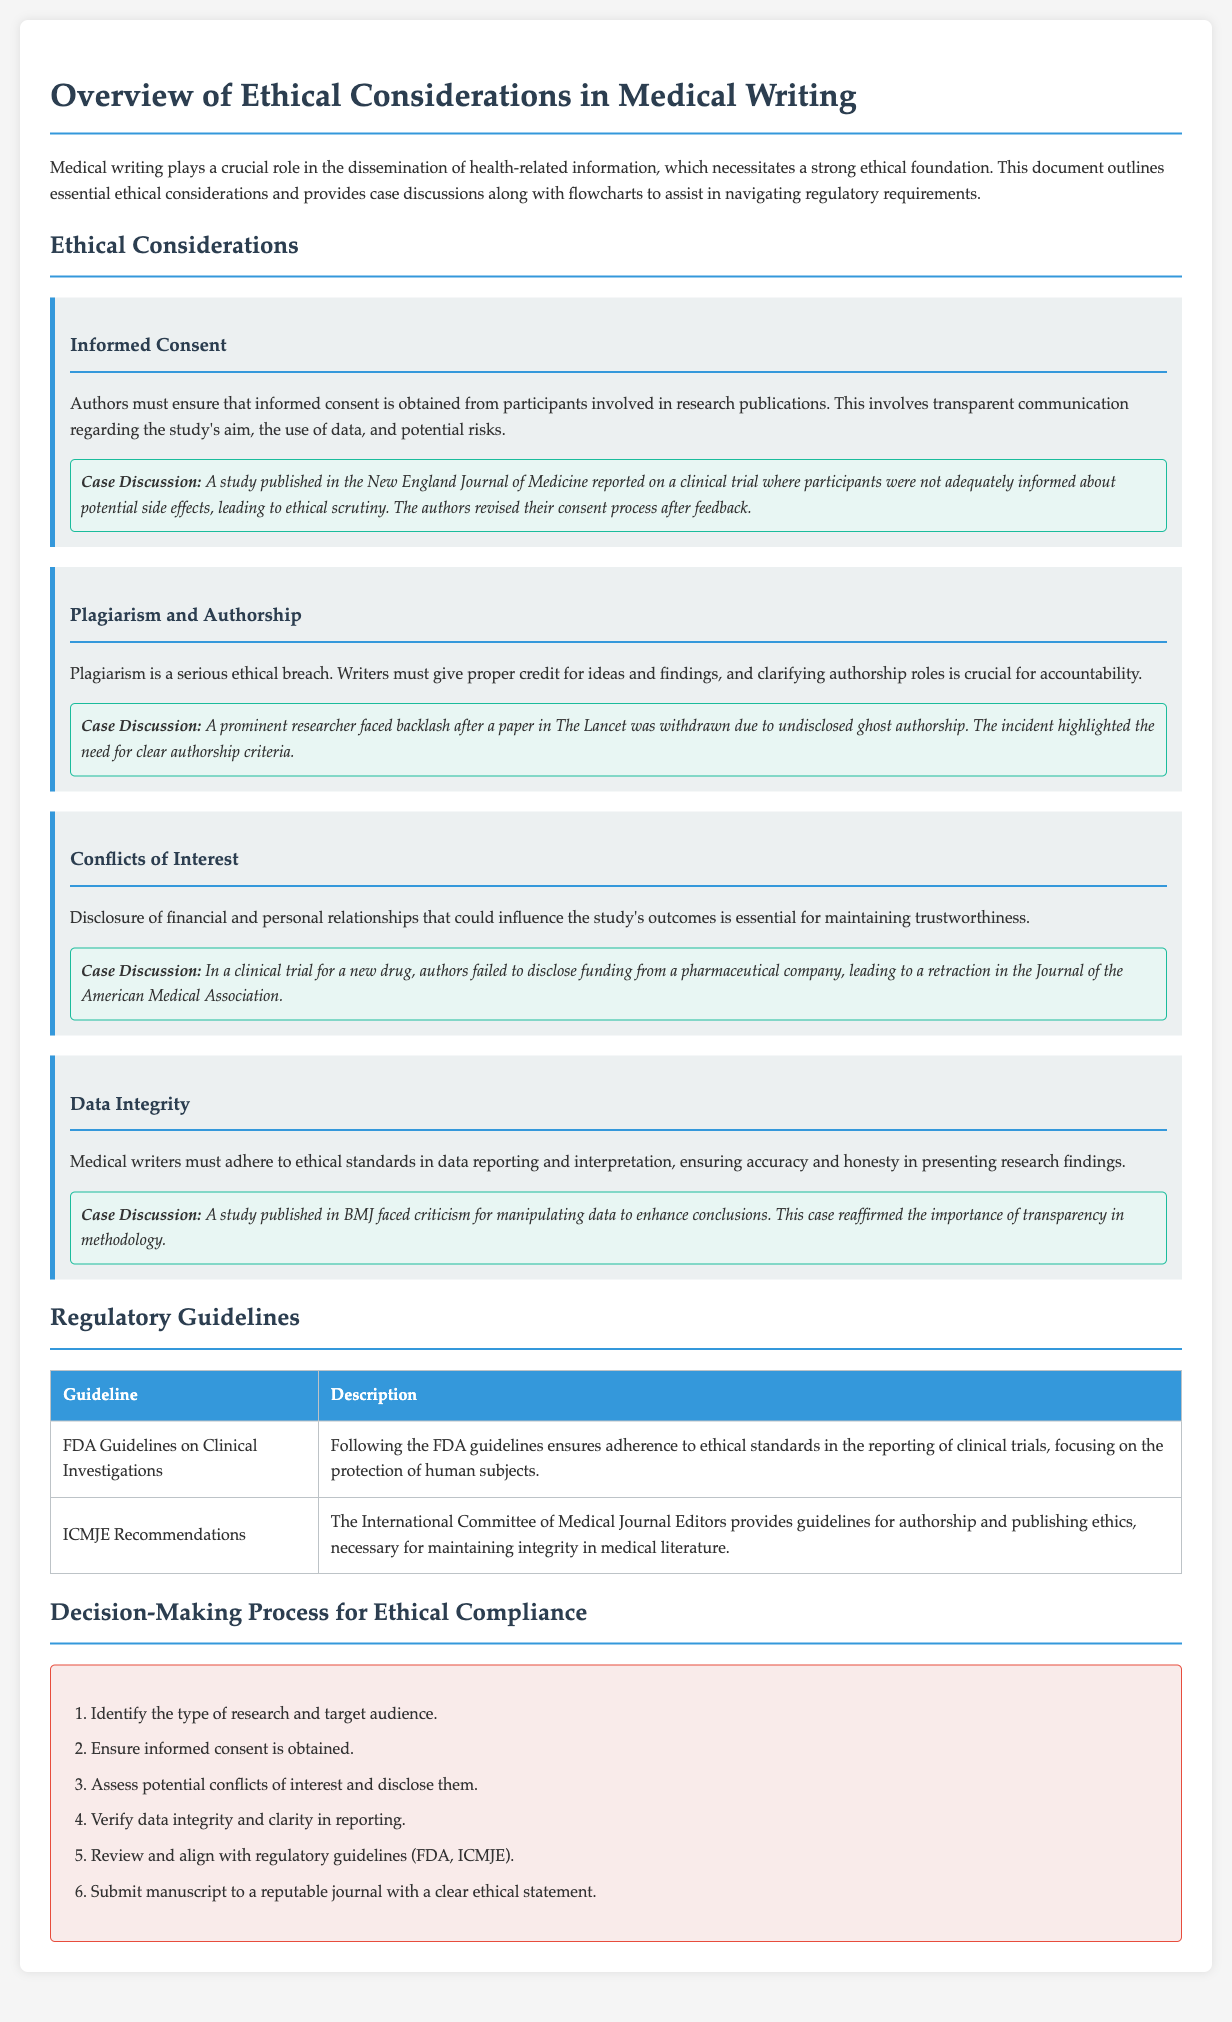What are ethical considerations in medical writing? The document outlines essential ethical considerations, including informed consent, plagiarism and authorship, conflicts of interest, and data integrity.
Answer: Informed consent, plagiarism and authorship, conflicts of interest, data integrity What is required for informed consent? Informed consent involves transparent communication regarding the study's aim, the use of data, and potential risks.
Answer: Transparent communication What was a consequence of failing to disclose funding in a clinical trial? The failure to disclose funding from a pharmaceutical company led to a retraction in the Journal of the American Medical Association.
Answer: Retraction What does the FDA guideline focus on? The FDA guidelines ensure adherence to ethical standards in the reporting of clinical trials, focusing on the protection of human subjects.
Answer: Protection of human subjects Which organization provides guidelines for authorship and publishing ethics? The International Committee of Medical Journal Editors provides guidelines necessary for maintaining integrity in medical literature.
Answer: ICMJE What is the first step in the decision-making process for ethical compliance? The first step is to identify the type of research and target audience.
Answer: Identify the type of research and target audience How many key ethical considerations are highlighted in the document? There are four ethical considerations explicitly mentioned in the document: informed consent, plagiarism and authorship, conflicts of interest, and data integrity.
Answer: Four What publication faced backlash due to undisclosed ghost authorship? A prominent researcher faced backlash after a paper in The Lancet was withdrawn due to undisclosed ghost authorship.
Answer: The Lancet 